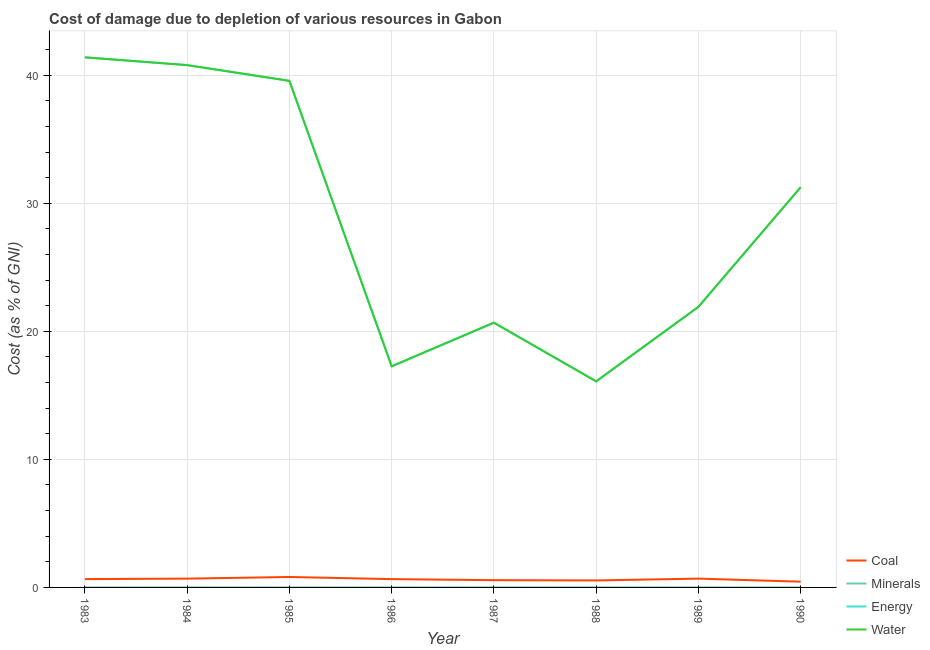How many different coloured lines are there?
Offer a very short reply. 4. Does the line corresponding to cost of damage due to depletion of energy intersect with the line corresponding to cost of damage due to depletion of coal?
Make the answer very short. No. Is the number of lines equal to the number of legend labels?
Your answer should be very brief. Yes. What is the cost of damage due to depletion of coal in 1989?
Your response must be concise. 0.69. Across all years, what is the maximum cost of damage due to depletion of coal?
Offer a terse response. 0.82. Across all years, what is the minimum cost of damage due to depletion of energy?
Make the answer very short. 16.09. What is the total cost of damage due to depletion of energy in the graph?
Keep it short and to the point. 228.91. What is the difference between the cost of damage due to depletion of coal in 1983 and that in 1988?
Keep it short and to the point. 0.11. What is the difference between the cost of damage due to depletion of energy in 1989 and the cost of damage due to depletion of coal in 1986?
Your response must be concise. 21.26. What is the average cost of damage due to depletion of coal per year?
Your answer should be very brief. 0.63. In the year 1988, what is the difference between the cost of damage due to depletion of water and cost of damage due to depletion of minerals?
Provide a short and direct response. 16.09. What is the ratio of the cost of damage due to depletion of energy in 1985 to that in 1990?
Your response must be concise. 1.27. What is the difference between the highest and the second highest cost of damage due to depletion of energy?
Ensure brevity in your answer.  0.61. What is the difference between the highest and the lowest cost of damage due to depletion of energy?
Provide a succinct answer. 25.3. Is it the case that in every year, the sum of the cost of damage due to depletion of energy and cost of damage due to depletion of minerals is greater than the sum of cost of damage due to depletion of water and cost of damage due to depletion of coal?
Keep it short and to the point. No. Does the cost of damage due to depletion of minerals monotonically increase over the years?
Keep it short and to the point. No. Is the cost of damage due to depletion of water strictly greater than the cost of damage due to depletion of minerals over the years?
Your answer should be compact. Yes. Are the values on the major ticks of Y-axis written in scientific E-notation?
Your answer should be compact. No. Does the graph contain any zero values?
Ensure brevity in your answer.  No. Where does the legend appear in the graph?
Your answer should be very brief. Bottom right. What is the title of the graph?
Offer a terse response. Cost of damage due to depletion of various resources in Gabon . Does "Macroeconomic management" appear as one of the legend labels in the graph?
Offer a very short reply. No. What is the label or title of the Y-axis?
Offer a very short reply. Cost (as % of GNI). What is the Cost (as % of GNI) in Coal in 1983?
Your answer should be compact. 0.65. What is the Cost (as % of GNI) in Minerals in 1983?
Ensure brevity in your answer.  0. What is the Cost (as % of GNI) of Energy in 1983?
Your answer should be very brief. 41.39. What is the Cost (as % of GNI) of Water in 1983?
Offer a very short reply. 41.39. What is the Cost (as % of GNI) of Coal in 1984?
Ensure brevity in your answer.  0.69. What is the Cost (as % of GNI) of Minerals in 1984?
Your answer should be very brief. 0. What is the Cost (as % of GNI) in Energy in 1984?
Provide a succinct answer. 40.78. What is the Cost (as % of GNI) of Water in 1984?
Keep it short and to the point. 40.79. What is the Cost (as % of GNI) of Coal in 1985?
Give a very brief answer. 0.82. What is the Cost (as % of GNI) in Minerals in 1985?
Make the answer very short. 0. What is the Cost (as % of GNI) of Energy in 1985?
Your answer should be very brief. 39.56. What is the Cost (as % of GNI) of Water in 1985?
Make the answer very short. 39.56. What is the Cost (as % of GNI) of Coal in 1986?
Offer a terse response. 0.65. What is the Cost (as % of GNI) in Minerals in 1986?
Your response must be concise. 0. What is the Cost (as % of GNI) of Energy in 1986?
Give a very brief answer. 17.27. What is the Cost (as % of GNI) of Water in 1986?
Your answer should be compact. 17.27. What is the Cost (as % of GNI) in Coal in 1987?
Give a very brief answer. 0.57. What is the Cost (as % of GNI) of Minerals in 1987?
Give a very brief answer. 0.01. What is the Cost (as % of GNI) of Energy in 1987?
Your answer should be compact. 20.67. What is the Cost (as % of GNI) of Water in 1987?
Ensure brevity in your answer.  20.68. What is the Cost (as % of GNI) in Coal in 1988?
Your answer should be compact. 0.55. What is the Cost (as % of GNI) of Minerals in 1988?
Make the answer very short. 0.01. What is the Cost (as % of GNI) of Energy in 1988?
Provide a succinct answer. 16.09. What is the Cost (as % of GNI) in Water in 1988?
Your answer should be compact. 16.09. What is the Cost (as % of GNI) of Coal in 1989?
Provide a succinct answer. 0.69. What is the Cost (as % of GNI) of Minerals in 1989?
Provide a short and direct response. 0. What is the Cost (as % of GNI) in Energy in 1989?
Provide a short and direct response. 21.91. What is the Cost (as % of GNI) of Water in 1989?
Offer a terse response. 21.91. What is the Cost (as % of GNI) of Coal in 1990?
Keep it short and to the point. 0.45. What is the Cost (as % of GNI) in Minerals in 1990?
Provide a short and direct response. 0. What is the Cost (as % of GNI) of Energy in 1990?
Ensure brevity in your answer.  31.25. What is the Cost (as % of GNI) in Water in 1990?
Ensure brevity in your answer.  31.25. Across all years, what is the maximum Cost (as % of GNI) in Coal?
Ensure brevity in your answer.  0.82. Across all years, what is the maximum Cost (as % of GNI) in Minerals?
Offer a very short reply. 0.01. Across all years, what is the maximum Cost (as % of GNI) in Energy?
Your answer should be very brief. 41.39. Across all years, what is the maximum Cost (as % of GNI) in Water?
Provide a short and direct response. 41.39. Across all years, what is the minimum Cost (as % of GNI) in Coal?
Your response must be concise. 0.45. Across all years, what is the minimum Cost (as % of GNI) in Minerals?
Make the answer very short. 0. Across all years, what is the minimum Cost (as % of GNI) of Energy?
Keep it short and to the point. 16.09. Across all years, what is the minimum Cost (as % of GNI) of Water?
Make the answer very short. 16.09. What is the total Cost (as % of GNI) in Coal in the graph?
Provide a short and direct response. 5.05. What is the total Cost (as % of GNI) of Minerals in the graph?
Provide a succinct answer. 0.03. What is the total Cost (as % of GNI) in Energy in the graph?
Offer a terse response. 228.91. What is the total Cost (as % of GNI) in Water in the graph?
Offer a very short reply. 228.94. What is the difference between the Cost (as % of GNI) of Coal in 1983 and that in 1984?
Ensure brevity in your answer.  -0.04. What is the difference between the Cost (as % of GNI) of Minerals in 1983 and that in 1984?
Your answer should be compact. -0. What is the difference between the Cost (as % of GNI) of Energy in 1983 and that in 1984?
Give a very brief answer. 0.61. What is the difference between the Cost (as % of GNI) of Water in 1983 and that in 1984?
Your answer should be very brief. 0.61. What is the difference between the Cost (as % of GNI) in Coal in 1983 and that in 1985?
Keep it short and to the point. -0.16. What is the difference between the Cost (as % of GNI) of Minerals in 1983 and that in 1985?
Your answer should be compact. -0. What is the difference between the Cost (as % of GNI) in Energy in 1983 and that in 1985?
Offer a very short reply. 1.84. What is the difference between the Cost (as % of GNI) in Water in 1983 and that in 1985?
Offer a terse response. 1.84. What is the difference between the Cost (as % of GNI) in Coal in 1983 and that in 1986?
Offer a terse response. 0. What is the difference between the Cost (as % of GNI) of Minerals in 1983 and that in 1986?
Offer a terse response. -0. What is the difference between the Cost (as % of GNI) in Energy in 1983 and that in 1986?
Your answer should be compact. 24.13. What is the difference between the Cost (as % of GNI) in Water in 1983 and that in 1986?
Your answer should be compact. 24.13. What is the difference between the Cost (as % of GNI) of Coal in 1983 and that in 1987?
Your answer should be very brief. 0.08. What is the difference between the Cost (as % of GNI) in Minerals in 1983 and that in 1987?
Keep it short and to the point. -0. What is the difference between the Cost (as % of GNI) in Energy in 1983 and that in 1987?
Offer a terse response. 20.72. What is the difference between the Cost (as % of GNI) in Water in 1983 and that in 1987?
Offer a terse response. 20.72. What is the difference between the Cost (as % of GNI) in Coal in 1983 and that in 1988?
Give a very brief answer. 0.1. What is the difference between the Cost (as % of GNI) of Minerals in 1983 and that in 1988?
Ensure brevity in your answer.  -0.01. What is the difference between the Cost (as % of GNI) in Energy in 1983 and that in 1988?
Offer a terse response. 25.3. What is the difference between the Cost (as % of GNI) of Water in 1983 and that in 1988?
Ensure brevity in your answer.  25.3. What is the difference between the Cost (as % of GNI) in Coal in 1983 and that in 1989?
Offer a very short reply. -0.04. What is the difference between the Cost (as % of GNI) of Minerals in 1983 and that in 1989?
Offer a terse response. -0. What is the difference between the Cost (as % of GNI) of Energy in 1983 and that in 1989?
Offer a terse response. 19.49. What is the difference between the Cost (as % of GNI) of Water in 1983 and that in 1989?
Offer a very short reply. 19.48. What is the difference between the Cost (as % of GNI) of Coal in 1983 and that in 1990?
Give a very brief answer. 0.2. What is the difference between the Cost (as % of GNI) in Energy in 1983 and that in 1990?
Provide a short and direct response. 10.14. What is the difference between the Cost (as % of GNI) in Water in 1983 and that in 1990?
Keep it short and to the point. 10.14. What is the difference between the Cost (as % of GNI) in Coal in 1984 and that in 1985?
Provide a succinct answer. -0.13. What is the difference between the Cost (as % of GNI) of Energy in 1984 and that in 1985?
Provide a short and direct response. 1.23. What is the difference between the Cost (as % of GNI) in Water in 1984 and that in 1985?
Provide a short and direct response. 1.23. What is the difference between the Cost (as % of GNI) of Coal in 1984 and that in 1986?
Offer a terse response. 0.04. What is the difference between the Cost (as % of GNI) in Minerals in 1984 and that in 1986?
Offer a very short reply. -0. What is the difference between the Cost (as % of GNI) in Energy in 1984 and that in 1986?
Offer a terse response. 23.52. What is the difference between the Cost (as % of GNI) in Water in 1984 and that in 1986?
Keep it short and to the point. 23.52. What is the difference between the Cost (as % of GNI) of Coal in 1984 and that in 1987?
Keep it short and to the point. 0.12. What is the difference between the Cost (as % of GNI) in Minerals in 1984 and that in 1987?
Give a very brief answer. -0. What is the difference between the Cost (as % of GNI) of Energy in 1984 and that in 1987?
Offer a very short reply. 20.12. What is the difference between the Cost (as % of GNI) in Water in 1984 and that in 1987?
Your response must be concise. 20.11. What is the difference between the Cost (as % of GNI) in Coal in 1984 and that in 1988?
Make the answer very short. 0.14. What is the difference between the Cost (as % of GNI) of Minerals in 1984 and that in 1988?
Offer a very short reply. -0.01. What is the difference between the Cost (as % of GNI) of Energy in 1984 and that in 1988?
Make the answer very short. 24.7. What is the difference between the Cost (as % of GNI) of Water in 1984 and that in 1988?
Your answer should be compact. 24.69. What is the difference between the Cost (as % of GNI) in Coal in 1984 and that in 1989?
Your response must be concise. -0. What is the difference between the Cost (as % of GNI) of Minerals in 1984 and that in 1989?
Offer a very short reply. 0. What is the difference between the Cost (as % of GNI) in Energy in 1984 and that in 1989?
Your answer should be very brief. 18.88. What is the difference between the Cost (as % of GNI) of Water in 1984 and that in 1989?
Your answer should be very brief. 18.88. What is the difference between the Cost (as % of GNI) of Coal in 1984 and that in 1990?
Your answer should be very brief. 0.24. What is the difference between the Cost (as % of GNI) of Minerals in 1984 and that in 1990?
Offer a terse response. 0. What is the difference between the Cost (as % of GNI) of Energy in 1984 and that in 1990?
Give a very brief answer. 9.54. What is the difference between the Cost (as % of GNI) of Water in 1984 and that in 1990?
Offer a terse response. 9.54. What is the difference between the Cost (as % of GNI) in Coal in 1985 and that in 1986?
Keep it short and to the point. 0.17. What is the difference between the Cost (as % of GNI) of Minerals in 1985 and that in 1986?
Make the answer very short. -0. What is the difference between the Cost (as % of GNI) of Energy in 1985 and that in 1986?
Offer a terse response. 22.29. What is the difference between the Cost (as % of GNI) of Water in 1985 and that in 1986?
Ensure brevity in your answer.  22.29. What is the difference between the Cost (as % of GNI) in Coal in 1985 and that in 1987?
Your response must be concise. 0.25. What is the difference between the Cost (as % of GNI) of Minerals in 1985 and that in 1987?
Offer a terse response. -0. What is the difference between the Cost (as % of GNI) of Energy in 1985 and that in 1987?
Make the answer very short. 18.89. What is the difference between the Cost (as % of GNI) in Water in 1985 and that in 1987?
Keep it short and to the point. 18.88. What is the difference between the Cost (as % of GNI) in Coal in 1985 and that in 1988?
Offer a very short reply. 0.27. What is the difference between the Cost (as % of GNI) of Minerals in 1985 and that in 1988?
Your answer should be compact. -0.01. What is the difference between the Cost (as % of GNI) of Energy in 1985 and that in 1988?
Your response must be concise. 23.47. What is the difference between the Cost (as % of GNI) in Water in 1985 and that in 1988?
Your answer should be very brief. 23.46. What is the difference between the Cost (as % of GNI) in Coal in 1985 and that in 1989?
Offer a terse response. 0.13. What is the difference between the Cost (as % of GNI) of Minerals in 1985 and that in 1989?
Keep it short and to the point. -0. What is the difference between the Cost (as % of GNI) of Energy in 1985 and that in 1989?
Provide a succinct answer. 17.65. What is the difference between the Cost (as % of GNI) of Water in 1985 and that in 1989?
Keep it short and to the point. 17.65. What is the difference between the Cost (as % of GNI) in Coal in 1985 and that in 1990?
Ensure brevity in your answer.  0.37. What is the difference between the Cost (as % of GNI) in Minerals in 1985 and that in 1990?
Give a very brief answer. 0. What is the difference between the Cost (as % of GNI) of Energy in 1985 and that in 1990?
Your response must be concise. 8.31. What is the difference between the Cost (as % of GNI) of Water in 1985 and that in 1990?
Offer a terse response. 8.31. What is the difference between the Cost (as % of GNI) of Coal in 1986 and that in 1987?
Provide a succinct answer. 0.08. What is the difference between the Cost (as % of GNI) of Minerals in 1986 and that in 1987?
Your response must be concise. -0. What is the difference between the Cost (as % of GNI) of Energy in 1986 and that in 1987?
Your response must be concise. -3.4. What is the difference between the Cost (as % of GNI) of Water in 1986 and that in 1987?
Your answer should be compact. -3.41. What is the difference between the Cost (as % of GNI) in Coal in 1986 and that in 1988?
Give a very brief answer. 0.1. What is the difference between the Cost (as % of GNI) in Minerals in 1986 and that in 1988?
Your answer should be compact. -0. What is the difference between the Cost (as % of GNI) of Energy in 1986 and that in 1988?
Offer a very short reply. 1.18. What is the difference between the Cost (as % of GNI) in Water in 1986 and that in 1988?
Your answer should be compact. 1.17. What is the difference between the Cost (as % of GNI) of Coal in 1986 and that in 1989?
Give a very brief answer. -0.04. What is the difference between the Cost (as % of GNI) in Minerals in 1986 and that in 1989?
Provide a succinct answer. 0. What is the difference between the Cost (as % of GNI) of Energy in 1986 and that in 1989?
Make the answer very short. -4.64. What is the difference between the Cost (as % of GNI) of Water in 1986 and that in 1989?
Offer a very short reply. -4.64. What is the difference between the Cost (as % of GNI) of Coal in 1986 and that in 1990?
Your answer should be very brief. 0.2. What is the difference between the Cost (as % of GNI) of Minerals in 1986 and that in 1990?
Ensure brevity in your answer.  0. What is the difference between the Cost (as % of GNI) of Energy in 1986 and that in 1990?
Offer a very short reply. -13.98. What is the difference between the Cost (as % of GNI) in Water in 1986 and that in 1990?
Offer a terse response. -13.98. What is the difference between the Cost (as % of GNI) in Coal in 1987 and that in 1988?
Give a very brief answer. 0.02. What is the difference between the Cost (as % of GNI) of Minerals in 1987 and that in 1988?
Offer a terse response. -0. What is the difference between the Cost (as % of GNI) of Energy in 1987 and that in 1988?
Give a very brief answer. 4.58. What is the difference between the Cost (as % of GNI) in Water in 1987 and that in 1988?
Provide a short and direct response. 4.58. What is the difference between the Cost (as % of GNI) of Coal in 1987 and that in 1989?
Keep it short and to the point. -0.12. What is the difference between the Cost (as % of GNI) in Minerals in 1987 and that in 1989?
Give a very brief answer. 0. What is the difference between the Cost (as % of GNI) of Energy in 1987 and that in 1989?
Provide a succinct answer. -1.24. What is the difference between the Cost (as % of GNI) in Water in 1987 and that in 1989?
Provide a short and direct response. -1.23. What is the difference between the Cost (as % of GNI) in Coal in 1987 and that in 1990?
Your answer should be compact. 0.12. What is the difference between the Cost (as % of GNI) of Minerals in 1987 and that in 1990?
Offer a terse response. 0. What is the difference between the Cost (as % of GNI) of Energy in 1987 and that in 1990?
Offer a very short reply. -10.58. What is the difference between the Cost (as % of GNI) in Water in 1987 and that in 1990?
Your answer should be very brief. -10.57. What is the difference between the Cost (as % of GNI) of Coal in 1988 and that in 1989?
Give a very brief answer. -0.14. What is the difference between the Cost (as % of GNI) in Minerals in 1988 and that in 1989?
Your answer should be compact. 0.01. What is the difference between the Cost (as % of GNI) in Energy in 1988 and that in 1989?
Ensure brevity in your answer.  -5.82. What is the difference between the Cost (as % of GNI) in Water in 1988 and that in 1989?
Your answer should be very brief. -5.81. What is the difference between the Cost (as % of GNI) of Coal in 1988 and that in 1990?
Offer a very short reply. 0.1. What is the difference between the Cost (as % of GNI) in Minerals in 1988 and that in 1990?
Provide a succinct answer. 0.01. What is the difference between the Cost (as % of GNI) in Energy in 1988 and that in 1990?
Keep it short and to the point. -15.16. What is the difference between the Cost (as % of GNI) of Water in 1988 and that in 1990?
Give a very brief answer. -15.15. What is the difference between the Cost (as % of GNI) in Coal in 1989 and that in 1990?
Ensure brevity in your answer.  0.24. What is the difference between the Cost (as % of GNI) of Minerals in 1989 and that in 1990?
Offer a very short reply. 0. What is the difference between the Cost (as % of GNI) in Energy in 1989 and that in 1990?
Your answer should be very brief. -9.34. What is the difference between the Cost (as % of GNI) of Water in 1989 and that in 1990?
Provide a succinct answer. -9.34. What is the difference between the Cost (as % of GNI) in Coal in 1983 and the Cost (as % of GNI) in Minerals in 1984?
Make the answer very short. 0.65. What is the difference between the Cost (as % of GNI) of Coal in 1983 and the Cost (as % of GNI) of Energy in 1984?
Your response must be concise. -40.13. What is the difference between the Cost (as % of GNI) of Coal in 1983 and the Cost (as % of GNI) of Water in 1984?
Keep it short and to the point. -40.14. What is the difference between the Cost (as % of GNI) in Minerals in 1983 and the Cost (as % of GNI) in Energy in 1984?
Your response must be concise. -40.78. What is the difference between the Cost (as % of GNI) of Minerals in 1983 and the Cost (as % of GNI) of Water in 1984?
Make the answer very short. -40.79. What is the difference between the Cost (as % of GNI) in Energy in 1983 and the Cost (as % of GNI) in Water in 1984?
Offer a very short reply. 0.61. What is the difference between the Cost (as % of GNI) of Coal in 1983 and the Cost (as % of GNI) of Minerals in 1985?
Provide a short and direct response. 0.65. What is the difference between the Cost (as % of GNI) in Coal in 1983 and the Cost (as % of GNI) in Energy in 1985?
Ensure brevity in your answer.  -38.91. What is the difference between the Cost (as % of GNI) of Coal in 1983 and the Cost (as % of GNI) of Water in 1985?
Keep it short and to the point. -38.91. What is the difference between the Cost (as % of GNI) in Minerals in 1983 and the Cost (as % of GNI) in Energy in 1985?
Offer a very short reply. -39.55. What is the difference between the Cost (as % of GNI) of Minerals in 1983 and the Cost (as % of GNI) of Water in 1985?
Make the answer very short. -39.56. What is the difference between the Cost (as % of GNI) in Energy in 1983 and the Cost (as % of GNI) in Water in 1985?
Keep it short and to the point. 1.83. What is the difference between the Cost (as % of GNI) in Coal in 1983 and the Cost (as % of GNI) in Minerals in 1986?
Keep it short and to the point. 0.65. What is the difference between the Cost (as % of GNI) in Coal in 1983 and the Cost (as % of GNI) in Energy in 1986?
Offer a very short reply. -16.61. What is the difference between the Cost (as % of GNI) in Coal in 1983 and the Cost (as % of GNI) in Water in 1986?
Your answer should be very brief. -16.62. What is the difference between the Cost (as % of GNI) of Minerals in 1983 and the Cost (as % of GNI) of Energy in 1986?
Your answer should be compact. -17.26. What is the difference between the Cost (as % of GNI) of Minerals in 1983 and the Cost (as % of GNI) of Water in 1986?
Keep it short and to the point. -17.27. What is the difference between the Cost (as % of GNI) in Energy in 1983 and the Cost (as % of GNI) in Water in 1986?
Ensure brevity in your answer.  24.12. What is the difference between the Cost (as % of GNI) in Coal in 1983 and the Cost (as % of GNI) in Minerals in 1987?
Ensure brevity in your answer.  0.65. What is the difference between the Cost (as % of GNI) in Coal in 1983 and the Cost (as % of GNI) in Energy in 1987?
Your answer should be compact. -20.02. What is the difference between the Cost (as % of GNI) in Coal in 1983 and the Cost (as % of GNI) in Water in 1987?
Provide a succinct answer. -20.02. What is the difference between the Cost (as % of GNI) of Minerals in 1983 and the Cost (as % of GNI) of Energy in 1987?
Your answer should be compact. -20.67. What is the difference between the Cost (as % of GNI) of Minerals in 1983 and the Cost (as % of GNI) of Water in 1987?
Offer a very short reply. -20.67. What is the difference between the Cost (as % of GNI) of Energy in 1983 and the Cost (as % of GNI) of Water in 1987?
Your answer should be very brief. 20.72. What is the difference between the Cost (as % of GNI) in Coal in 1983 and the Cost (as % of GNI) in Minerals in 1988?
Keep it short and to the point. 0.64. What is the difference between the Cost (as % of GNI) of Coal in 1983 and the Cost (as % of GNI) of Energy in 1988?
Your answer should be very brief. -15.44. What is the difference between the Cost (as % of GNI) of Coal in 1983 and the Cost (as % of GNI) of Water in 1988?
Provide a succinct answer. -15.44. What is the difference between the Cost (as % of GNI) of Minerals in 1983 and the Cost (as % of GNI) of Energy in 1988?
Offer a terse response. -16.09. What is the difference between the Cost (as % of GNI) of Minerals in 1983 and the Cost (as % of GNI) of Water in 1988?
Keep it short and to the point. -16.09. What is the difference between the Cost (as % of GNI) of Energy in 1983 and the Cost (as % of GNI) of Water in 1988?
Offer a very short reply. 25.3. What is the difference between the Cost (as % of GNI) of Coal in 1983 and the Cost (as % of GNI) of Minerals in 1989?
Provide a short and direct response. 0.65. What is the difference between the Cost (as % of GNI) in Coal in 1983 and the Cost (as % of GNI) in Energy in 1989?
Keep it short and to the point. -21.26. What is the difference between the Cost (as % of GNI) of Coal in 1983 and the Cost (as % of GNI) of Water in 1989?
Ensure brevity in your answer.  -21.26. What is the difference between the Cost (as % of GNI) in Minerals in 1983 and the Cost (as % of GNI) in Energy in 1989?
Your answer should be very brief. -21.91. What is the difference between the Cost (as % of GNI) in Minerals in 1983 and the Cost (as % of GNI) in Water in 1989?
Give a very brief answer. -21.91. What is the difference between the Cost (as % of GNI) in Energy in 1983 and the Cost (as % of GNI) in Water in 1989?
Offer a terse response. 19.48. What is the difference between the Cost (as % of GNI) in Coal in 1983 and the Cost (as % of GNI) in Minerals in 1990?
Give a very brief answer. 0.65. What is the difference between the Cost (as % of GNI) of Coal in 1983 and the Cost (as % of GNI) of Energy in 1990?
Keep it short and to the point. -30.6. What is the difference between the Cost (as % of GNI) of Coal in 1983 and the Cost (as % of GNI) of Water in 1990?
Your response must be concise. -30.6. What is the difference between the Cost (as % of GNI) of Minerals in 1983 and the Cost (as % of GNI) of Energy in 1990?
Provide a succinct answer. -31.25. What is the difference between the Cost (as % of GNI) in Minerals in 1983 and the Cost (as % of GNI) in Water in 1990?
Provide a succinct answer. -31.25. What is the difference between the Cost (as % of GNI) of Energy in 1983 and the Cost (as % of GNI) of Water in 1990?
Your response must be concise. 10.14. What is the difference between the Cost (as % of GNI) of Coal in 1984 and the Cost (as % of GNI) of Minerals in 1985?
Ensure brevity in your answer.  0.69. What is the difference between the Cost (as % of GNI) in Coal in 1984 and the Cost (as % of GNI) in Energy in 1985?
Your answer should be compact. -38.87. What is the difference between the Cost (as % of GNI) in Coal in 1984 and the Cost (as % of GNI) in Water in 1985?
Offer a very short reply. -38.87. What is the difference between the Cost (as % of GNI) in Minerals in 1984 and the Cost (as % of GNI) in Energy in 1985?
Your answer should be very brief. -39.55. What is the difference between the Cost (as % of GNI) in Minerals in 1984 and the Cost (as % of GNI) in Water in 1985?
Make the answer very short. -39.56. What is the difference between the Cost (as % of GNI) of Energy in 1984 and the Cost (as % of GNI) of Water in 1985?
Provide a short and direct response. 1.23. What is the difference between the Cost (as % of GNI) in Coal in 1984 and the Cost (as % of GNI) in Minerals in 1986?
Provide a succinct answer. 0.68. What is the difference between the Cost (as % of GNI) of Coal in 1984 and the Cost (as % of GNI) of Energy in 1986?
Provide a short and direct response. -16.58. What is the difference between the Cost (as % of GNI) of Coal in 1984 and the Cost (as % of GNI) of Water in 1986?
Your answer should be very brief. -16.58. What is the difference between the Cost (as % of GNI) of Minerals in 1984 and the Cost (as % of GNI) of Energy in 1986?
Make the answer very short. -17.26. What is the difference between the Cost (as % of GNI) of Minerals in 1984 and the Cost (as % of GNI) of Water in 1986?
Ensure brevity in your answer.  -17.27. What is the difference between the Cost (as % of GNI) in Energy in 1984 and the Cost (as % of GNI) in Water in 1986?
Offer a very short reply. 23.52. What is the difference between the Cost (as % of GNI) of Coal in 1984 and the Cost (as % of GNI) of Minerals in 1987?
Offer a terse response. 0.68. What is the difference between the Cost (as % of GNI) in Coal in 1984 and the Cost (as % of GNI) in Energy in 1987?
Offer a terse response. -19.98. What is the difference between the Cost (as % of GNI) of Coal in 1984 and the Cost (as % of GNI) of Water in 1987?
Offer a terse response. -19.99. What is the difference between the Cost (as % of GNI) in Minerals in 1984 and the Cost (as % of GNI) in Energy in 1987?
Give a very brief answer. -20.67. What is the difference between the Cost (as % of GNI) of Minerals in 1984 and the Cost (as % of GNI) of Water in 1987?
Give a very brief answer. -20.67. What is the difference between the Cost (as % of GNI) in Energy in 1984 and the Cost (as % of GNI) in Water in 1987?
Provide a short and direct response. 20.11. What is the difference between the Cost (as % of GNI) in Coal in 1984 and the Cost (as % of GNI) in Minerals in 1988?
Make the answer very short. 0.68. What is the difference between the Cost (as % of GNI) of Coal in 1984 and the Cost (as % of GNI) of Energy in 1988?
Provide a short and direct response. -15.4. What is the difference between the Cost (as % of GNI) of Coal in 1984 and the Cost (as % of GNI) of Water in 1988?
Offer a terse response. -15.41. What is the difference between the Cost (as % of GNI) of Minerals in 1984 and the Cost (as % of GNI) of Energy in 1988?
Your response must be concise. -16.09. What is the difference between the Cost (as % of GNI) in Minerals in 1984 and the Cost (as % of GNI) in Water in 1988?
Give a very brief answer. -16.09. What is the difference between the Cost (as % of GNI) of Energy in 1984 and the Cost (as % of GNI) of Water in 1988?
Offer a very short reply. 24.69. What is the difference between the Cost (as % of GNI) of Coal in 1984 and the Cost (as % of GNI) of Minerals in 1989?
Keep it short and to the point. 0.69. What is the difference between the Cost (as % of GNI) of Coal in 1984 and the Cost (as % of GNI) of Energy in 1989?
Offer a terse response. -21.22. What is the difference between the Cost (as % of GNI) in Coal in 1984 and the Cost (as % of GNI) in Water in 1989?
Give a very brief answer. -21.22. What is the difference between the Cost (as % of GNI) of Minerals in 1984 and the Cost (as % of GNI) of Energy in 1989?
Offer a terse response. -21.91. What is the difference between the Cost (as % of GNI) of Minerals in 1984 and the Cost (as % of GNI) of Water in 1989?
Your answer should be very brief. -21.91. What is the difference between the Cost (as % of GNI) in Energy in 1984 and the Cost (as % of GNI) in Water in 1989?
Offer a terse response. 18.87. What is the difference between the Cost (as % of GNI) in Coal in 1984 and the Cost (as % of GNI) in Minerals in 1990?
Make the answer very short. 0.69. What is the difference between the Cost (as % of GNI) of Coal in 1984 and the Cost (as % of GNI) of Energy in 1990?
Keep it short and to the point. -30.56. What is the difference between the Cost (as % of GNI) in Coal in 1984 and the Cost (as % of GNI) in Water in 1990?
Ensure brevity in your answer.  -30.56. What is the difference between the Cost (as % of GNI) of Minerals in 1984 and the Cost (as % of GNI) of Energy in 1990?
Your response must be concise. -31.25. What is the difference between the Cost (as % of GNI) of Minerals in 1984 and the Cost (as % of GNI) of Water in 1990?
Provide a succinct answer. -31.25. What is the difference between the Cost (as % of GNI) in Energy in 1984 and the Cost (as % of GNI) in Water in 1990?
Offer a very short reply. 9.54. What is the difference between the Cost (as % of GNI) of Coal in 1985 and the Cost (as % of GNI) of Minerals in 1986?
Make the answer very short. 0.81. What is the difference between the Cost (as % of GNI) of Coal in 1985 and the Cost (as % of GNI) of Energy in 1986?
Ensure brevity in your answer.  -16.45. What is the difference between the Cost (as % of GNI) of Coal in 1985 and the Cost (as % of GNI) of Water in 1986?
Provide a short and direct response. -16.45. What is the difference between the Cost (as % of GNI) of Minerals in 1985 and the Cost (as % of GNI) of Energy in 1986?
Keep it short and to the point. -17.26. What is the difference between the Cost (as % of GNI) in Minerals in 1985 and the Cost (as % of GNI) in Water in 1986?
Your response must be concise. -17.27. What is the difference between the Cost (as % of GNI) of Energy in 1985 and the Cost (as % of GNI) of Water in 1986?
Your response must be concise. 22.29. What is the difference between the Cost (as % of GNI) in Coal in 1985 and the Cost (as % of GNI) in Minerals in 1987?
Offer a very short reply. 0.81. What is the difference between the Cost (as % of GNI) of Coal in 1985 and the Cost (as % of GNI) of Energy in 1987?
Provide a succinct answer. -19.85. What is the difference between the Cost (as % of GNI) in Coal in 1985 and the Cost (as % of GNI) in Water in 1987?
Provide a succinct answer. -19.86. What is the difference between the Cost (as % of GNI) of Minerals in 1985 and the Cost (as % of GNI) of Energy in 1987?
Provide a short and direct response. -20.67. What is the difference between the Cost (as % of GNI) of Minerals in 1985 and the Cost (as % of GNI) of Water in 1987?
Ensure brevity in your answer.  -20.67. What is the difference between the Cost (as % of GNI) of Energy in 1985 and the Cost (as % of GNI) of Water in 1987?
Your response must be concise. 18.88. What is the difference between the Cost (as % of GNI) in Coal in 1985 and the Cost (as % of GNI) in Minerals in 1988?
Give a very brief answer. 0.81. What is the difference between the Cost (as % of GNI) in Coal in 1985 and the Cost (as % of GNI) in Energy in 1988?
Your answer should be compact. -15.27. What is the difference between the Cost (as % of GNI) in Coal in 1985 and the Cost (as % of GNI) in Water in 1988?
Offer a terse response. -15.28. What is the difference between the Cost (as % of GNI) in Minerals in 1985 and the Cost (as % of GNI) in Energy in 1988?
Give a very brief answer. -16.09. What is the difference between the Cost (as % of GNI) in Minerals in 1985 and the Cost (as % of GNI) in Water in 1988?
Your answer should be compact. -16.09. What is the difference between the Cost (as % of GNI) of Energy in 1985 and the Cost (as % of GNI) of Water in 1988?
Give a very brief answer. 23.46. What is the difference between the Cost (as % of GNI) of Coal in 1985 and the Cost (as % of GNI) of Minerals in 1989?
Keep it short and to the point. 0.81. What is the difference between the Cost (as % of GNI) of Coal in 1985 and the Cost (as % of GNI) of Energy in 1989?
Your response must be concise. -21.09. What is the difference between the Cost (as % of GNI) in Coal in 1985 and the Cost (as % of GNI) in Water in 1989?
Your answer should be compact. -21.09. What is the difference between the Cost (as % of GNI) of Minerals in 1985 and the Cost (as % of GNI) of Energy in 1989?
Your response must be concise. -21.91. What is the difference between the Cost (as % of GNI) of Minerals in 1985 and the Cost (as % of GNI) of Water in 1989?
Provide a succinct answer. -21.91. What is the difference between the Cost (as % of GNI) of Energy in 1985 and the Cost (as % of GNI) of Water in 1989?
Ensure brevity in your answer.  17.65. What is the difference between the Cost (as % of GNI) in Coal in 1985 and the Cost (as % of GNI) in Minerals in 1990?
Your response must be concise. 0.81. What is the difference between the Cost (as % of GNI) of Coal in 1985 and the Cost (as % of GNI) of Energy in 1990?
Your answer should be very brief. -30.43. What is the difference between the Cost (as % of GNI) of Coal in 1985 and the Cost (as % of GNI) of Water in 1990?
Provide a succinct answer. -30.43. What is the difference between the Cost (as % of GNI) of Minerals in 1985 and the Cost (as % of GNI) of Energy in 1990?
Your response must be concise. -31.25. What is the difference between the Cost (as % of GNI) of Minerals in 1985 and the Cost (as % of GNI) of Water in 1990?
Give a very brief answer. -31.25. What is the difference between the Cost (as % of GNI) of Energy in 1985 and the Cost (as % of GNI) of Water in 1990?
Keep it short and to the point. 8.31. What is the difference between the Cost (as % of GNI) in Coal in 1986 and the Cost (as % of GNI) in Minerals in 1987?
Provide a short and direct response. 0.64. What is the difference between the Cost (as % of GNI) in Coal in 1986 and the Cost (as % of GNI) in Energy in 1987?
Offer a terse response. -20.02. What is the difference between the Cost (as % of GNI) in Coal in 1986 and the Cost (as % of GNI) in Water in 1987?
Make the answer very short. -20.03. What is the difference between the Cost (as % of GNI) in Minerals in 1986 and the Cost (as % of GNI) in Energy in 1987?
Make the answer very short. -20.67. What is the difference between the Cost (as % of GNI) in Minerals in 1986 and the Cost (as % of GNI) in Water in 1987?
Your answer should be compact. -20.67. What is the difference between the Cost (as % of GNI) in Energy in 1986 and the Cost (as % of GNI) in Water in 1987?
Make the answer very short. -3.41. What is the difference between the Cost (as % of GNI) of Coal in 1986 and the Cost (as % of GNI) of Minerals in 1988?
Offer a very short reply. 0.64. What is the difference between the Cost (as % of GNI) of Coal in 1986 and the Cost (as % of GNI) of Energy in 1988?
Keep it short and to the point. -15.44. What is the difference between the Cost (as % of GNI) of Coal in 1986 and the Cost (as % of GNI) of Water in 1988?
Offer a terse response. -15.45. What is the difference between the Cost (as % of GNI) of Minerals in 1986 and the Cost (as % of GNI) of Energy in 1988?
Offer a terse response. -16.08. What is the difference between the Cost (as % of GNI) in Minerals in 1986 and the Cost (as % of GNI) in Water in 1988?
Offer a terse response. -16.09. What is the difference between the Cost (as % of GNI) in Energy in 1986 and the Cost (as % of GNI) in Water in 1988?
Provide a short and direct response. 1.17. What is the difference between the Cost (as % of GNI) of Coal in 1986 and the Cost (as % of GNI) of Minerals in 1989?
Offer a terse response. 0.65. What is the difference between the Cost (as % of GNI) of Coal in 1986 and the Cost (as % of GNI) of Energy in 1989?
Ensure brevity in your answer.  -21.26. What is the difference between the Cost (as % of GNI) of Coal in 1986 and the Cost (as % of GNI) of Water in 1989?
Offer a very short reply. -21.26. What is the difference between the Cost (as % of GNI) of Minerals in 1986 and the Cost (as % of GNI) of Energy in 1989?
Keep it short and to the point. -21.9. What is the difference between the Cost (as % of GNI) of Minerals in 1986 and the Cost (as % of GNI) of Water in 1989?
Ensure brevity in your answer.  -21.91. What is the difference between the Cost (as % of GNI) in Energy in 1986 and the Cost (as % of GNI) in Water in 1989?
Make the answer very short. -4.64. What is the difference between the Cost (as % of GNI) in Coal in 1986 and the Cost (as % of GNI) in Minerals in 1990?
Keep it short and to the point. 0.65. What is the difference between the Cost (as % of GNI) of Coal in 1986 and the Cost (as % of GNI) of Energy in 1990?
Provide a short and direct response. -30.6. What is the difference between the Cost (as % of GNI) of Coal in 1986 and the Cost (as % of GNI) of Water in 1990?
Keep it short and to the point. -30.6. What is the difference between the Cost (as % of GNI) of Minerals in 1986 and the Cost (as % of GNI) of Energy in 1990?
Provide a short and direct response. -31.24. What is the difference between the Cost (as % of GNI) in Minerals in 1986 and the Cost (as % of GNI) in Water in 1990?
Ensure brevity in your answer.  -31.25. What is the difference between the Cost (as % of GNI) in Energy in 1986 and the Cost (as % of GNI) in Water in 1990?
Your response must be concise. -13.98. What is the difference between the Cost (as % of GNI) in Coal in 1987 and the Cost (as % of GNI) in Minerals in 1988?
Give a very brief answer. 0.56. What is the difference between the Cost (as % of GNI) in Coal in 1987 and the Cost (as % of GNI) in Energy in 1988?
Offer a terse response. -15.52. What is the difference between the Cost (as % of GNI) of Coal in 1987 and the Cost (as % of GNI) of Water in 1988?
Your response must be concise. -15.53. What is the difference between the Cost (as % of GNI) of Minerals in 1987 and the Cost (as % of GNI) of Energy in 1988?
Offer a very short reply. -16.08. What is the difference between the Cost (as % of GNI) of Minerals in 1987 and the Cost (as % of GNI) of Water in 1988?
Your response must be concise. -16.09. What is the difference between the Cost (as % of GNI) in Energy in 1987 and the Cost (as % of GNI) in Water in 1988?
Your answer should be very brief. 4.57. What is the difference between the Cost (as % of GNI) in Coal in 1987 and the Cost (as % of GNI) in Minerals in 1989?
Your answer should be compact. 0.56. What is the difference between the Cost (as % of GNI) in Coal in 1987 and the Cost (as % of GNI) in Energy in 1989?
Your answer should be very brief. -21.34. What is the difference between the Cost (as % of GNI) in Coal in 1987 and the Cost (as % of GNI) in Water in 1989?
Your response must be concise. -21.34. What is the difference between the Cost (as % of GNI) of Minerals in 1987 and the Cost (as % of GNI) of Energy in 1989?
Your response must be concise. -21.9. What is the difference between the Cost (as % of GNI) in Minerals in 1987 and the Cost (as % of GNI) in Water in 1989?
Make the answer very short. -21.9. What is the difference between the Cost (as % of GNI) in Energy in 1987 and the Cost (as % of GNI) in Water in 1989?
Make the answer very short. -1.24. What is the difference between the Cost (as % of GNI) of Coal in 1987 and the Cost (as % of GNI) of Minerals in 1990?
Offer a very short reply. 0.56. What is the difference between the Cost (as % of GNI) of Coal in 1987 and the Cost (as % of GNI) of Energy in 1990?
Your answer should be compact. -30.68. What is the difference between the Cost (as % of GNI) of Coal in 1987 and the Cost (as % of GNI) of Water in 1990?
Offer a terse response. -30.68. What is the difference between the Cost (as % of GNI) of Minerals in 1987 and the Cost (as % of GNI) of Energy in 1990?
Keep it short and to the point. -31.24. What is the difference between the Cost (as % of GNI) of Minerals in 1987 and the Cost (as % of GNI) of Water in 1990?
Make the answer very short. -31.24. What is the difference between the Cost (as % of GNI) in Energy in 1987 and the Cost (as % of GNI) in Water in 1990?
Your response must be concise. -10.58. What is the difference between the Cost (as % of GNI) of Coal in 1988 and the Cost (as % of GNI) of Minerals in 1989?
Give a very brief answer. 0.54. What is the difference between the Cost (as % of GNI) in Coal in 1988 and the Cost (as % of GNI) in Energy in 1989?
Your response must be concise. -21.36. What is the difference between the Cost (as % of GNI) in Coal in 1988 and the Cost (as % of GNI) in Water in 1989?
Offer a terse response. -21.36. What is the difference between the Cost (as % of GNI) of Minerals in 1988 and the Cost (as % of GNI) of Energy in 1989?
Provide a succinct answer. -21.9. What is the difference between the Cost (as % of GNI) of Minerals in 1988 and the Cost (as % of GNI) of Water in 1989?
Provide a succinct answer. -21.9. What is the difference between the Cost (as % of GNI) of Energy in 1988 and the Cost (as % of GNI) of Water in 1989?
Your answer should be compact. -5.82. What is the difference between the Cost (as % of GNI) of Coal in 1988 and the Cost (as % of GNI) of Minerals in 1990?
Ensure brevity in your answer.  0.54. What is the difference between the Cost (as % of GNI) of Coal in 1988 and the Cost (as % of GNI) of Energy in 1990?
Make the answer very short. -30.7. What is the difference between the Cost (as % of GNI) in Coal in 1988 and the Cost (as % of GNI) in Water in 1990?
Your response must be concise. -30.7. What is the difference between the Cost (as % of GNI) in Minerals in 1988 and the Cost (as % of GNI) in Energy in 1990?
Your response must be concise. -31.24. What is the difference between the Cost (as % of GNI) in Minerals in 1988 and the Cost (as % of GNI) in Water in 1990?
Give a very brief answer. -31.24. What is the difference between the Cost (as % of GNI) in Energy in 1988 and the Cost (as % of GNI) in Water in 1990?
Provide a succinct answer. -15.16. What is the difference between the Cost (as % of GNI) of Coal in 1989 and the Cost (as % of GNI) of Minerals in 1990?
Keep it short and to the point. 0.69. What is the difference between the Cost (as % of GNI) of Coal in 1989 and the Cost (as % of GNI) of Energy in 1990?
Your answer should be very brief. -30.56. What is the difference between the Cost (as % of GNI) in Coal in 1989 and the Cost (as % of GNI) in Water in 1990?
Keep it short and to the point. -30.56. What is the difference between the Cost (as % of GNI) of Minerals in 1989 and the Cost (as % of GNI) of Energy in 1990?
Ensure brevity in your answer.  -31.25. What is the difference between the Cost (as % of GNI) in Minerals in 1989 and the Cost (as % of GNI) in Water in 1990?
Your answer should be compact. -31.25. What is the difference between the Cost (as % of GNI) in Energy in 1989 and the Cost (as % of GNI) in Water in 1990?
Offer a terse response. -9.34. What is the average Cost (as % of GNI) in Coal per year?
Offer a terse response. 0.63. What is the average Cost (as % of GNI) of Minerals per year?
Give a very brief answer. 0. What is the average Cost (as % of GNI) of Energy per year?
Ensure brevity in your answer.  28.61. What is the average Cost (as % of GNI) of Water per year?
Offer a very short reply. 28.62. In the year 1983, what is the difference between the Cost (as % of GNI) of Coal and Cost (as % of GNI) of Minerals?
Provide a short and direct response. 0.65. In the year 1983, what is the difference between the Cost (as % of GNI) of Coal and Cost (as % of GNI) of Energy?
Your response must be concise. -40.74. In the year 1983, what is the difference between the Cost (as % of GNI) of Coal and Cost (as % of GNI) of Water?
Your answer should be very brief. -40.74. In the year 1983, what is the difference between the Cost (as % of GNI) of Minerals and Cost (as % of GNI) of Energy?
Give a very brief answer. -41.39. In the year 1983, what is the difference between the Cost (as % of GNI) of Minerals and Cost (as % of GNI) of Water?
Offer a terse response. -41.39. In the year 1983, what is the difference between the Cost (as % of GNI) of Energy and Cost (as % of GNI) of Water?
Make the answer very short. -0. In the year 1984, what is the difference between the Cost (as % of GNI) of Coal and Cost (as % of GNI) of Minerals?
Provide a short and direct response. 0.69. In the year 1984, what is the difference between the Cost (as % of GNI) in Coal and Cost (as % of GNI) in Energy?
Your answer should be very brief. -40.1. In the year 1984, what is the difference between the Cost (as % of GNI) in Coal and Cost (as % of GNI) in Water?
Make the answer very short. -40.1. In the year 1984, what is the difference between the Cost (as % of GNI) of Minerals and Cost (as % of GNI) of Energy?
Give a very brief answer. -40.78. In the year 1984, what is the difference between the Cost (as % of GNI) in Minerals and Cost (as % of GNI) in Water?
Ensure brevity in your answer.  -40.78. In the year 1984, what is the difference between the Cost (as % of GNI) in Energy and Cost (as % of GNI) in Water?
Your answer should be very brief. -0. In the year 1985, what is the difference between the Cost (as % of GNI) of Coal and Cost (as % of GNI) of Minerals?
Provide a short and direct response. 0.81. In the year 1985, what is the difference between the Cost (as % of GNI) in Coal and Cost (as % of GNI) in Energy?
Your answer should be compact. -38.74. In the year 1985, what is the difference between the Cost (as % of GNI) in Coal and Cost (as % of GNI) in Water?
Ensure brevity in your answer.  -38.74. In the year 1985, what is the difference between the Cost (as % of GNI) in Minerals and Cost (as % of GNI) in Energy?
Ensure brevity in your answer.  -39.55. In the year 1985, what is the difference between the Cost (as % of GNI) of Minerals and Cost (as % of GNI) of Water?
Offer a terse response. -39.56. In the year 1985, what is the difference between the Cost (as % of GNI) of Energy and Cost (as % of GNI) of Water?
Give a very brief answer. -0. In the year 1986, what is the difference between the Cost (as % of GNI) in Coal and Cost (as % of GNI) in Minerals?
Your answer should be compact. 0.65. In the year 1986, what is the difference between the Cost (as % of GNI) in Coal and Cost (as % of GNI) in Energy?
Provide a succinct answer. -16.62. In the year 1986, what is the difference between the Cost (as % of GNI) in Coal and Cost (as % of GNI) in Water?
Make the answer very short. -16.62. In the year 1986, what is the difference between the Cost (as % of GNI) of Minerals and Cost (as % of GNI) of Energy?
Offer a very short reply. -17.26. In the year 1986, what is the difference between the Cost (as % of GNI) in Minerals and Cost (as % of GNI) in Water?
Provide a short and direct response. -17.27. In the year 1986, what is the difference between the Cost (as % of GNI) of Energy and Cost (as % of GNI) of Water?
Your answer should be very brief. -0. In the year 1987, what is the difference between the Cost (as % of GNI) of Coal and Cost (as % of GNI) of Minerals?
Ensure brevity in your answer.  0.56. In the year 1987, what is the difference between the Cost (as % of GNI) of Coal and Cost (as % of GNI) of Energy?
Offer a terse response. -20.1. In the year 1987, what is the difference between the Cost (as % of GNI) of Coal and Cost (as % of GNI) of Water?
Your response must be concise. -20.11. In the year 1987, what is the difference between the Cost (as % of GNI) in Minerals and Cost (as % of GNI) in Energy?
Provide a short and direct response. -20.66. In the year 1987, what is the difference between the Cost (as % of GNI) in Minerals and Cost (as % of GNI) in Water?
Offer a terse response. -20.67. In the year 1987, what is the difference between the Cost (as % of GNI) of Energy and Cost (as % of GNI) of Water?
Offer a very short reply. -0.01. In the year 1988, what is the difference between the Cost (as % of GNI) of Coal and Cost (as % of GNI) of Minerals?
Provide a succinct answer. 0.54. In the year 1988, what is the difference between the Cost (as % of GNI) in Coal and Cost (as % of GNI) in Energy?
Your answer should be very brief. -15.54. In the year 1988, what is the difference between the Cost (as % of GNI) in Coal and Cost (as % of GNI) in Water?
Your response must be concise. -15.55. In the year 1988, what is the difference between the Cost (as % of GNI) of Minerals and Cost (as % of GNI) of Energy?
Offer a terse response. -16.08. In the year 1988, what is the difference between the Cost (as % of GNI) in Minerals and Cost (as % of GNI) in Water?
Make the answer very short. -16.09. In the year 1988, what is the difference between the Cost (as % of GNI) of Energy and Cost (as % of GNI) of Water?
Give a very brief answer. -0.01. In the year 1989, what is the difference between the Cost (as % of GNI) of Coal and Cost (as % of GNI) of Minerals?
Your answer should be very brief. 0.69. In the year 1989, what is the difference between the Cost (as % of GNI) in Coal and Cost (as % of GNI) in Energy?
Offer a terse response. -21.22. In the year 1989, what is the difference between the Cost (as % of GNI) in Coal and Cost (as % of GNI) in Water?
Offer a very short reply. -21.22. In the year 1989, what is the difference between the Cost (as % of GNI) of Minerals and Cost (as % of GNI) of Energy?
Ensure brevity in your answer.  -21.91. In the year 1989, what is the difference between the Cost (as % of GNI) of Minerals and Cost (as % of GNI) of Water?
Offer a terse response. -21.91. In the year 1989, what is the difference between the Cost (as % of GNI) in Energy and Cost (as % of GNI) in Water?
Provide a short and direct response. -0. In the year 1990, what is the difference between the Cost (as % of GNI) in Coal and Cost (as % of GNI) in Minerals?
Your answer should be compact. 0.45. In the year 1990, what is the difference between the Cost (as % of GNI) in Coal and Cost (as % of GNI) in Energy?
Offer a terse response. -30.8. In the year 1990, what is the difference between the Cost (as % of GNI) of Coal and Cost (as % of GNI) of Water?
Ensure brevity in your answer.  -30.8. In the year 1990, what is the difference between the Cost (as % of GNI) of Minerals and Cost (as % of GNI) of Energy?
Ensure brevity in your answer.  -31.25. In the year 1990, what is the difference between the Cost (as % of GNI) in Minerals and Cost (as % of GNI) in Water?
Provide a short and direct response. -31.25. In the year 1990, what is the difference between the Cost (as % of GNI) of Energy and Cost (as % of GNI) of Water?
Give a very brief answer. -0. What is the ratio of the Cost (as % of GNI) in Coal in 1983 to that in 1984?
Ensure brevity in your answer.  0.95. What is the ratio of the Cost (as % of GNI) in Minerals in 1983 to that in 1984?
Give a very brief answer. 0.64. What is the ratio of the Cost (as % of GNI) of Energy in 1983 to that in 1984?
Keep it short and to the point. 1.01. What is the ratio of the Cost (as % of GNI) of Water in 1983 to that in 1984?
Your answer should be very brief. 1.01. What is the ratio of the Cost (as % of GNI) in Coal in 1983 to that in 1985?
Keep it short and to the point. 0.8. What is the ratio of the Cost (as % of GNI) of Minerals in 1983 to that in 1985?
Offer a very short reply. 0.7. What is the ratio of the Cost (as % of GNI) in Energy in 1983 to that in 1985?
Offer a very short reply. 1.05. What is the ratio of the Cost (as % of GNI) of Water in 1983 to that in 1985?
Your response must be concise. 1.05. What is the ratio of the Cost (as % of GNI) of Coal in 1983 to that in 1986?
Keep it short and to the point. 1. What is the ratio of the Cost (as % of GNI) of Minerals in 1983 to that in 1986?
Your response must be concise. 0.49. What is the ratio of the Cost (as % of GNI) of Energy in 1983 to that in 1986?
Offer a very short reply. 2.4. What is the ratio of the Cost (as % of GNI) in Water in 1983 to that in 1986?
Your answer should be very brief. 2.4. What is the ratio of the Cost (as % of GNI) of Coal in 1983 to that in 1987?
Ensure brevity in your answer.  1.15. What is the ratio of the Cost (as % of GNI) of Minerals in 1983 to that in 1987?
Give a very brief answer. 0.25. What is the ratio of the Cost (as % of GNI) of Energy in 1983 to that in 1987?
Ensure brevity in your answer.  2. What is the ratio of the Cost (as % of GNI) in Water in 1983 to that in 1987?
Your response must be concise. 2. What is the ratio of the Cost (as % of GNI) of Coal in 1983 to that in 1988?
Provide a short and direct response. 1.19. What is the ratio of the Cost (as % of GNI) in Minerals in 1983 to that in 1988?
Ensure brevity in your answer.  0.2. What is the ratio of the Cost (as % of GNI) in Energy in 1983 to that in 1988?
Make the answer very short. 2.57. What is the ratio of the Cost (as % of GNI) of Water in 1983 to that in 1988?
Make the answer very short. 2.57. What is the ratio of the Cost (as % of GNI) in Coal in 1983 to that in 1989?
Ensure brevity in your answer.  0.95. What is the ratio of the Cost (as % of GNI) of Minerals in 1983 to that in 1989?
Keep it short and to the point. 0.64. What is the ratio of the Cost (as % of GNI) in Energy in 1983 to that in 1989?
Offer a very short reply. 1.89. What is the ratio of the Cost (as % of GNI) of Water in 1983 to that in 1989?
Offer a very short reply. 1.89. What is the ratio of the Cost (as % of GNI) in Coal in 1983 to that in 1990?
Provide a succinct answer. 1.45. What is the ratio of the Cost (as % of GNI) of Minerals in 1983 to that in 1990?
Make the answer very short. 1. What is the ratio of the Cost (as % of GNI) of Energy in 1983 to that in 1990?
Provide a succinct answer. 1.32. What is the ratio of the Cost (as % of GNI) of Water in 1983 to that in 1990?
Make the answer very short. 1.32. What is the ratio of the Cost (as % of GNI) in Coal in 1984 to that in 1985?
Your response must be concise. 0.84. What is the ratio of the Cost (as % of GNI) of Minerals in 1984 to that in 1985?
Provide a short and direct response. 1.1. What is the ratio of the Cost (as % of GNI) of Energy in 1984 to that in 1985?
Offer a very short reply. 1.03. What is the ratio of the Cost (as % of GNI) in Water in 1984 to that in 1985?
Your response must be concise. 1.03. What is the ratio of the Cost (as % of GNI) in Coal in 1984 to that in 1986?
Provide a short and direct response. 1.06. What is the ratio of the Cost (as % of GNI) of Minerals in 1984 to that in 1986?
Make the answer very short. 0.77. What is the ratio of the Cost (as % of GNI) in Energy in 1984 to that in 1986?
Make the answer very short. 2.36. What is the ratio of the Cost (as % of GNI) in Water in 1984 to that in 1986?
Make the answer very short. 2.36. What is the ratio of the Cost (as % of GNI) in Coal in 1984 to that in 1987?
Make the answer very short. 1.21. What is the ratio of the Cost (as % of GNI) in Minerals in 1984 to that in 1987?
Keep it short and to the point. 0.39. What is the ratio of the Cost (as % of GNI) of Energy in 1984 to that in 1987?
Provide a succinct answer. 1.97. What is the ratio of the Cost (as % of GNI) of Water in 1984 to that in 1987?
Give a very brief answer. 1.97. What is the ratio of the Cost (as % of GNI) of Coal in 1984 to that in 1988?
Make the answer very short. 1.26. What is the ratio of the Cost (as % of GNI) of Minerals in 1984 to that in 1988?
Provide a succinct answer. 0.31. What is the ratio of the Cost (as % of GNI) in Energy in 1984 to that in 1988?
Ensure brevity in your answer.  2.54. What is the ratio of the Cost (as % of GNI) in Water in 1984 to that in 1988?
Offer a terse response. 2.53. What is the ratio of the Cost (as % of GNI) in Energy in 1984 to that in 1989?
Offer a very short reply. 1.86. What is the ratio of the Cost (as % of GNI) of Water in 1984 to that in 1989?
Offer a terse response. 1.86. What is the ratio of the Cost (as % of GNI) in Coal in 1984 to that in 1990?
Make the answer very short. 1.53. What is the ratio of the Cost (as % of GNI) of Minerals in 1984 to that in 1990?
Provide a succinct answer. 1.56. What is the ratio of the Cost (as % of GNI) in Energy in 1984 to that in 1990?
Your answer should be compact. 1.31. What is the ratio of the Cost (as % of GNI) of Water in 1984 to that in 1990?
Give a very brief answer. 1.31. What is the ratio of the Cost (as % of GNI) in Coal in 1985 to that in 1986?
Ensure brevity in your answer.  1.26. What is the ratio of the Cost (as % of GNI) in Minerals in 1985 to that in 1986?
Your response must be concise. 0.7. What is the ratio of the Cost (as % of GNI) of Energy in 1985 to that in 1986?
Offer a terse response. 2.29. What is the ratio of the Cost (as % of GNI) in Water in 1985 to that in 1986?
Offer a terse response. 2.29. What is the ratio of the Cost (as % of GNI) in Coal in 1985 to that in 1987?
Provide a succinct answer. 1.44. What is the ratio of the Cost (as % of GNI) in Minerals in 1985 to that in 1987?
Provide a succinct answer. 0.36. What is the ratio of the Cost (as % of GNI) in Energy in 1985 to that in 1987?
Make the answer very short. 1.91. What is the ratio of the Cost (as % of GNI) of Water in 1985 to that in 1987?
Your answer should be compact. 1.91. What is the ratio of the Cost (as % of GNI) of Coal in 1985 to that in 1988?
Make the answer very short. 1.49. What is the ratio of the Cost (as % of GNI) in Minerals in 1985 to that in 1988?
Keep it short and to the point. 0.29. What is the ratio of the Cost (as % of GNI) in Energy in 1985 to that in 1988?
Provide a short and direct response. 2.46. What is the ratio of the Cost (as % of GNI) of Water in 1985 to that in 1988?
Offer a terse response. 2.46. What is the ratio of the Cost (as % of GNI) in Coal in 1985 to that in 1989?
Make the answer very short. 1.19. What is the ratio of the Cost (as % of GNI) of Minerals in 1985 to that in 1989?
Ensure brevity in your answer.  0.91. What is the ratio of the Cost (as % of GNI) in Energy in 1985 to that in 1989?
Ensure brevity in your answer.  1.81. What is the ratio of the Cost (as % of GNI) in Water in 1985 to that in 1989?
Provide a short and direct response. 1.81. What is the ratio of the Cost (as % of GNI) of Coal in 1985 to that in 1990?
Ensure brevity in your answer.  1.82. What is the ratio of the Cost (as % of GNI) of Minerals in 1985 to that in 1990?
Ensure brevity in your answer.  1.42. What is the ratio of the Cost (as % of GNI) of Energy in 1985 to that in 1990?
Offer a terse response. 1.27. What is the ratio of the Cost (as % of GNI) in Water in 1985 to that in 1990?
Provide a short and direct response. 1.27. What is the ratio of the Cost (as % of GNI) in Coal in 1986 to that in 1987?
Your response must be concise. 1.15. What is the ratio of the Cost (as % of GNI) of Minerals in 1986 to that in 1987?
Your response must be concise. 0.51. What is the ratio of the Cost (as % of GNI) of Energy in 1986 to that in 1987?
Make the answer very short. 0.84. What is the ratio of the Cost (as % of GNI) in Water in 1986 to that in 1987?
Your response must be concise. 0.84. What is the ratio of the Cost (as % of GNI) of Coal in 1986 to that in 1988?
Provide a succinct answer. 1.19. What is the ratio of the Cost (as % of GNI) of Minerals in 1986 to that in 1988?
Your answer should be very brief. 0.41. What is the ratio of the Cost (as % of GNI) of Energy in 1986 to that in 1988?
Make the answer very short. 1.07. What is the ratio of the Cost (as % of GNI) of Water in 1986 to that in 1988?
Offer a very short reply. 1.07. What is the ratio of the Cost (as % of GNI) in Coal in 1986 to that in 1989?
Your answer should be very brief. 0.94. What is the ratio of the Cost (as % of GNI) of Minerals in 1986 to that in 1989?
Give a very brief answer. 1.3. What is the ratio of the Cost (as % of GNI) of Energy in 1986 to that in 1989?
Provide a short and direct response. 0.79. What is the ratio of the Cost (as % of GNI) in Water in 1986 to that in 1989?
Make the answer very short. 0.79. What is the ratio of the Cost (as % of GNI) of Coal in 1986 to that in 1990?
Ensure brevity in your answer.  1.45. What is the ratio of the Cost (as % of GNI) of Minerals in 1986 to that in 1990?
Give a very brief answer. 2.03. What is the ratio of the Cost (as % of GNI) in Energy in 1986 to that in 1990?
Provide a succinct answer. 0.55. What is the ratio of the Cost (as % of GNI) in Water in 1986 to that in 1990?
Give a very brief answer. 0.55. What is the ratio of the Cost (as % of GNI) of Coal in 1987 to that in 1988?
Your response must be concise. 1.04. What is the ratio of the Cost (as % of GNI) in Minerals in 1987 to that in 1988?
Give a very brief answer. 0.8. What is the ratio of the Cost (as % of GNI) in Energy in 1987 to that in 1988?
Keep it short and to the point. 1.28. What is the ratio of the Cost (as % of GNI) in Water in 1987 to that in 1988?
Offer a very short reply. 1.28. What is the ratio of the Cost (as % of GNI) in Coal in 1987 to that in 1989?
Ensure brevity in your answer.  0.82. What is the ratio of the Cost (as % of GNI) of Minerals in 1987 to that in 1989?
Offer a very short reply. 2.56. What is the ratio of the Cost (as % of GNI) in Energy in 1987 to that in 1989?
Your answer should be very brief. 0.94. What is the ratio of the Cost (as % of GNI) of Water in 1987 to that in 1989?
Give a very brief answer. 0.94. What is the ratio of the Cost (as % of GNI) of Coal in 1987 to that in 1990?
Make the answer very short. 1.26. What is the ratio of the Cost (as % of GNI) of Minerals in 1987 to that in 1990?
Ensure brevity in your answer.  3.99. What is the ratio of the Cost (as % of GNI) of Energy in 1987 to that in 1990?
Your answer should be compact. 0.66. What is the ratio of the Cost (as % of GNI) in Water in 1987 to that in 1990?
Offer a terse response. 0.66. What is the ratio of the Cost (as % of GNI) in Coal in 1988 to that in 1989?
Ensure brevity in your answer.  0.79. What is the ratio of the Cost (as % of GNI) of Minerals in 1988 to that in 1989?
Give a very brief answer. 3.2. What is the ratio of the Cost (as % of GNI) in Energy in 1988 to that in 1989?
Provide a short and direct response. 0.73. What is the ratio of the Cost (as % of GNI) of Water in 1988 to that in 1989?
Provide a succinct answer. 0.73. What is the ratio of the Cost (as % of GNI) in Coal in 1988 to that in 1990?
Your answer should be very brief. 1.22. What is the ratio of the Cost (as % of GNI) in Minerals in 1988 to that in 1990?
Your response must be concise. 4.98. What is the ratio of the Cost (as % of GNI) in Energy in 1988 to that in 1990?
Ensure brevity in your answer.  0.51. What is the ratio of the Cost (as % of GNI) of Water in 1988 to that in 1990?
Your response must be concise. 0.52. What is the ratio of the Cost (as % of GNI) of Coal in 1989 to that in 1990?
Your answer should be very brief. 1.53. What is the ratio of the Cost (as % of GNI) in Minerals in 1989 to that in 1990?
Provide a short and direct response. 1.56. What is the ratio of the Cost (as % of GNI) in Energy in 1989 to that in 1990?
Ensure brevity in your answer.  0.7. What is the ratio of the Cost (as % of GNI) in Water in 1989 to that in 1990?
Offer a very short reply. 0.7. What is the difference between the highest and the second highest Cost (as % of GNI) in Coal?
Offer a terse response. 0.13. What is the difference between the highest and the second highest Cost (as % of GNI) in Minerals?
Provide a succinct answer. 0. What is the difference between the highest and the second highest Cost (as % of GNI) in Energy?
Keep it short and to the point. 0.61. What is the difference between the highest and the second highest Cost (as % of GNI) of Water?
Provide a succinct answer. 0.61. What is the difference between the highest and the lowest Cost (as % of GNI) in Coal?
Your response must be concise. 0.37. What is the difference between the highest and the lowest Cost (as % of GNI) in Minerals?
Provide a short and direct response. 0.01. What is the difference between the highest and the lowest Cost (as % of GNI) of Energy?
Your response must be concise. 25.3. What is the difference between the highest and the lowest Cost (as % of GNI) in Water?
Offer a very short reply. 25.3. 